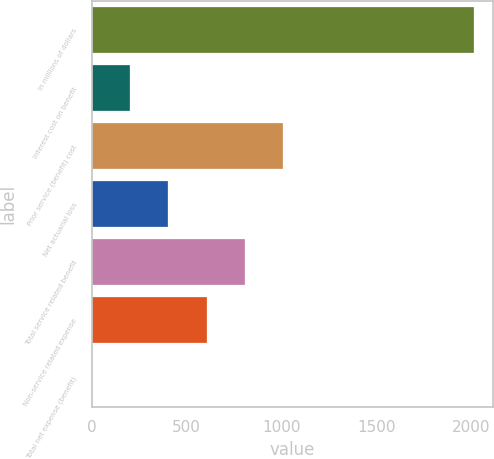Convert chart. <chart><loc_0><loc_0><loc_500><loc_500><bar_chart><fcel>In millions of dollars<fcel>Interest cost on benefit<fcel>Prior service (benefit) cost<fcel>Net actuarial loss<fcel>Total service related benefit<fcel>Non-service related expense<fcel>Total net expense (benefit)<nl><fcel>2016<fcel>203.4<fcel>1009<fcel>404.8<fcel>807.6<fcel>606.2<fcel>2<nl></chart> 